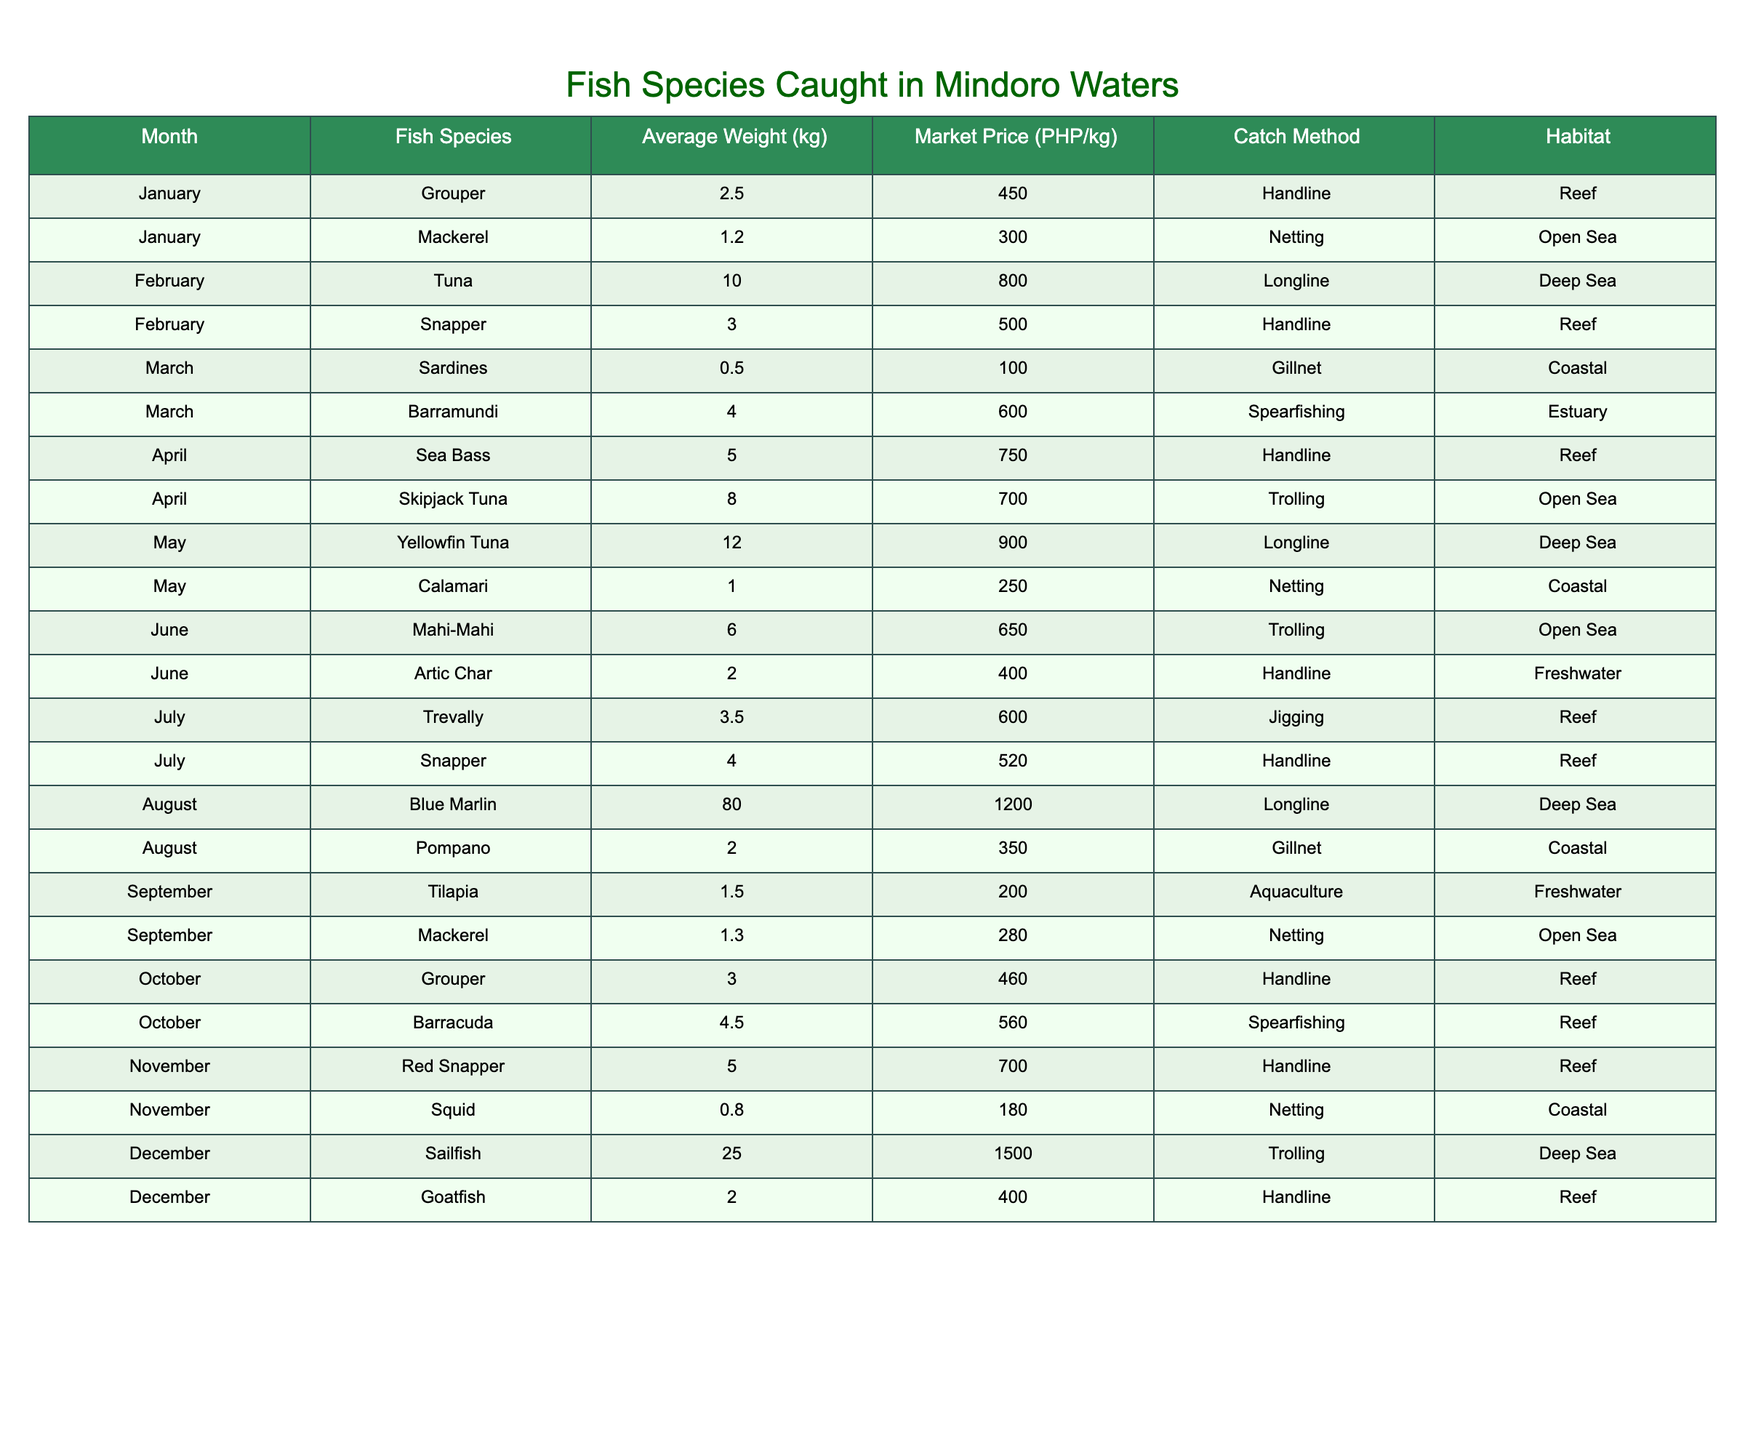What is the average weight of Yellowfin Tuna? The table shows only one entry for Yellowfin Tuna, which is 12.0 kg. Since there's only one value, the average weight is the same as the weight itself, which is 12.0 kg.
Answer: 12.0 kg Which fish species has the highest market price in December? In December, the table lists Sailfish with a market price of 1500 PHP/kg. It is the only fish species listed for that month, making it the highest price for December.
Answer: Sailfish Is it true that all fish species caught by handline method are found in reef habitats? By examining the rows, we see that Grouper, Snapper, Sea Bass, Barracuda, Red Snapper, and Goatfish are caught using handline, and all of them are indeed found in reef habitats. Therefore, the statement is true.
Answer: Yes What is the total average weight of fish species caught in November? The fish species caught in November are Red Snapper (5.0 kg) and Squid (0.8 kg). Adding these weights gives 5.0 + 0.8 = 5.8 kg. Thus, the total average weight for November is 5.8 kg.
Answer: 5.8 kg Which month has the lowest average weight of fish caught? By comparing the average weights for each month, March has the lowest average weight of fish caught with Sardines at 0.5 kg. Hence, March has the lowest catch weight.
Answer: March How many different fish species are caught in the open sea throughout the year? The table lists Mackerel (January), Skipjack Tuna (April), Yellowfin Tuna (May), Mahi-Mahi (June), and September Mackerel. This results in a total of 4 different species (Mackerel is listed twice).
Answer: 4 What is the total market price of all fish species caught in May? In May, Yellowfin Tuna (900 PHP/kg) and Calamari (250 PHP/kg) were caught. The total market price is 900 + 250 = 1150 PHP.
Answer: 1150 PHP Which fish species was caught with the highest average weight and what is the value? The table indicates that Blue Marlin was caught with the highest average weight of 80.0 kg. Hence, it is the fish species with the highest weight.
Answer: Blue Marlin, 80.0 kg In which month is the Barramundi fish caught and what is its catch method? According to the table, Barramundi is caught in March using the spearfishing method.
Answer: March, Spearfishing 